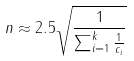Convert formula to latex. <formula><loc_0><loc_0><loc_500><loc_500>n \approx 2 . 5 \sqrt { \frac { 1 } { \sum _ { i = 1 } ^ { k } \frac { 1 } { c _ { i } } } }</formula> 